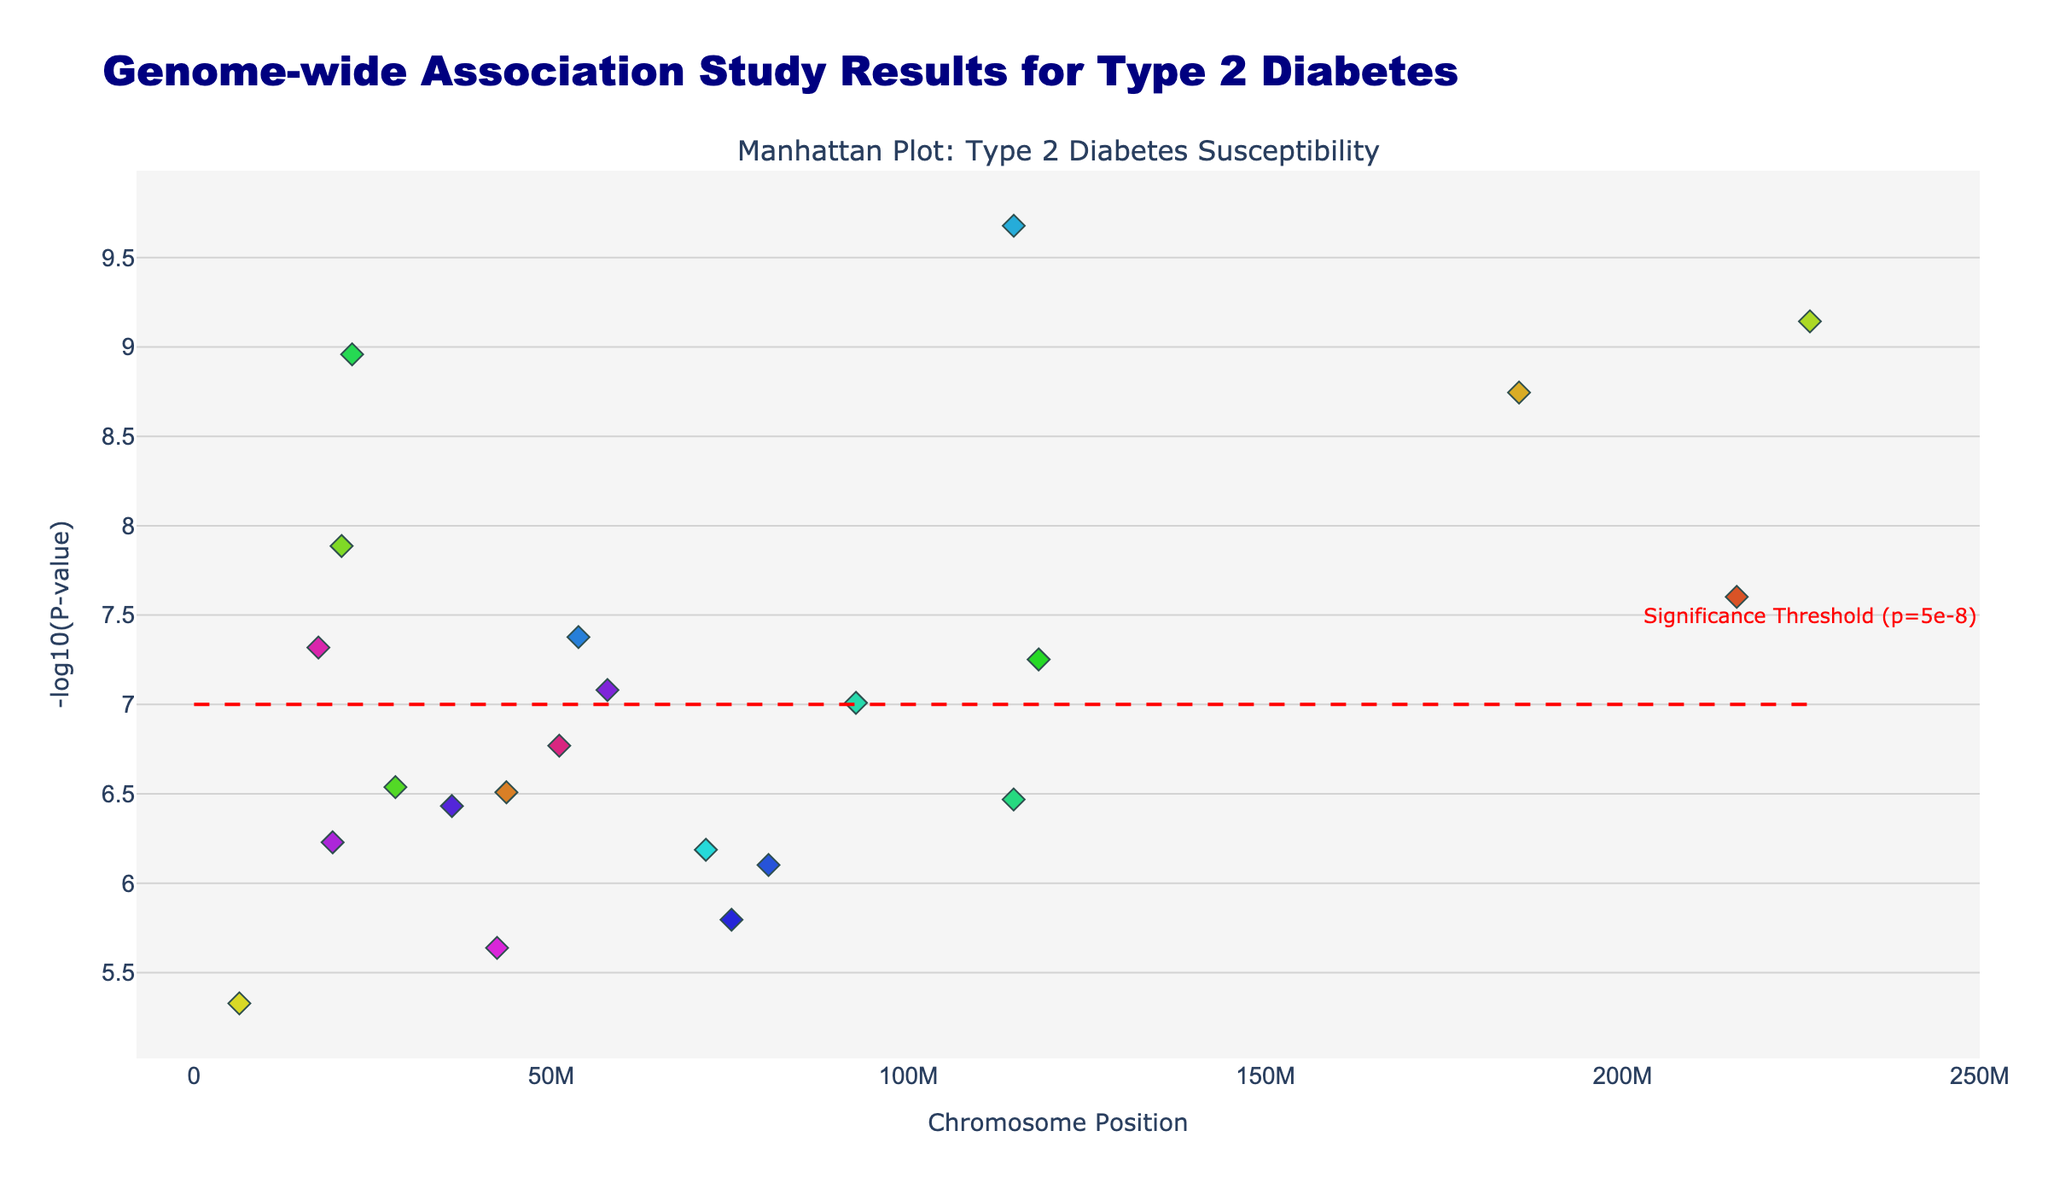What is the title of the figure? The title is located at the top of the figure. It reads 'Genome-wide Association Study Results for Type 2 Diabetes'.
Answer: Genome-wide Association Study Results for Type 2 Diabetes How many chromosomes are represented in the Manhattan plot? The Manhattan plot has 22 different colored scatter plots, each representing a chromosome numbered from 1 to 22.
Answer: 22 Which chromosome has the SNP with the lowest p-value? Identifying the lowest p-value is done by looking for the tallest point in the plot, which corresponds to the highest value on the -log10(P-value) axis. For this data, Chromosome 13 has the SNP with the lowest p-value, as indicated by the highest point in the plot.
Answer: Chromosome 13 How many SNPs have a significance level above the threshold line? The significance threshold is indicated by a red dashed line at a -log10(P-value) of 7. Counting the number of data points (SNPs) above this line results in 8 SNPs above the threshold.
Answer: 8 Which chromosome has the most significant SNP located furthest to the right? The position of the SNPs on each chromosome can be observed on the x-axis. The position further to the right indicates a larger chromosomal position value. Chromosome 1 has the furthest right significant SNP in this setting.
Answer: Chromosome 1 What is the significance threshold line in terms of -log10(P-value)? The significance threshold line is represented by a horizontal red dashed line, which is annotated. The label and position suggest it corresponds to -log10(P-value) = 7.
Answer: -log10(P-value) = 7 Which chromosomes have SNPs very close to but not above the significance threshold? By examining the height of points just below the red line (significance threshold), Chromosomes 2, 7, and 12 have points near this threshold without surpassing it.
Answer: Chromosomes 2, 7, and 12 What's the maximum -log10(P-value) for chromosome 9? Locate the chromosome 9 data points by color and then identify the maximum height on the y-axis. The maximum -log10(P-value) for chromosome 9 is 9.04, associated with SNP 'rs10811661'.
Answer: 9.04 (-log10(P-value)) How does SNP rs12255372 on chromosome 1 compare to SNP rs12970134 on chromosome 18 in terms of -log10(P-value)? Find and compare both marked SNPs' heights on the y-axis in terms of -log10(P-value). SNP rs12255372 (8.60) is slightly lower than SNP rs12970134 (8.08).
Answer: SNP rs12255372 is more significant 